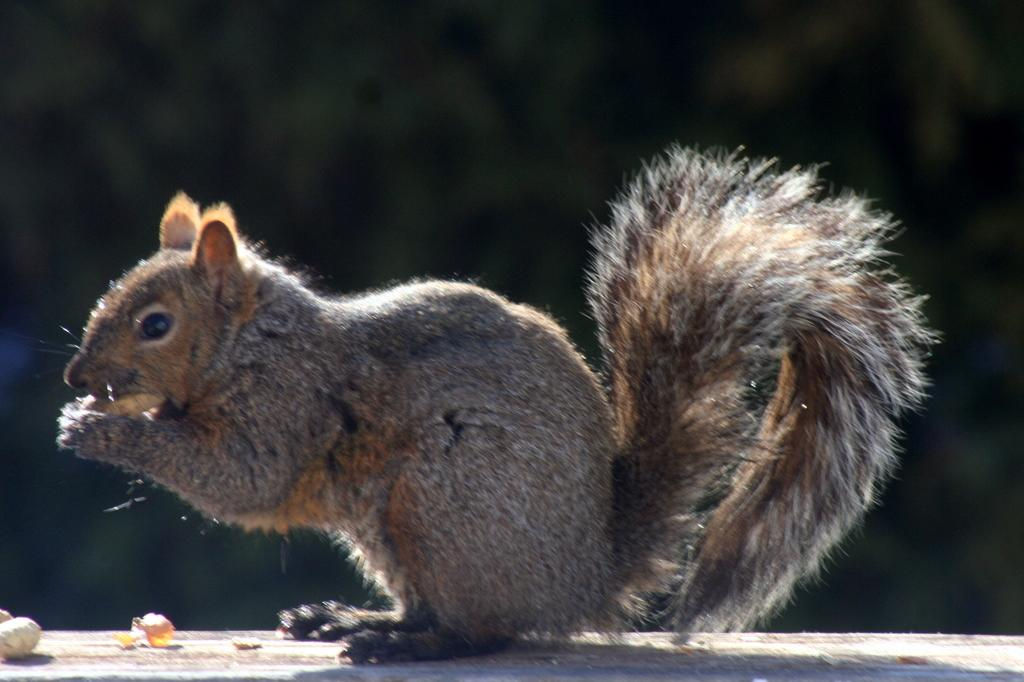What animal is present in the image? There is a squirrel in the image. What is the squirrel doing in the image? The squirrel is holding an object. What can be seen on a surface in the image? There are objects on a surface in the image. How would you describe the background of the image? The background of the image is dark in color. How many feathers can be seen growing from the squirrel's tail in the image? There are no feathers present in the image, and the squirrel's tail is not shown growing anything. 